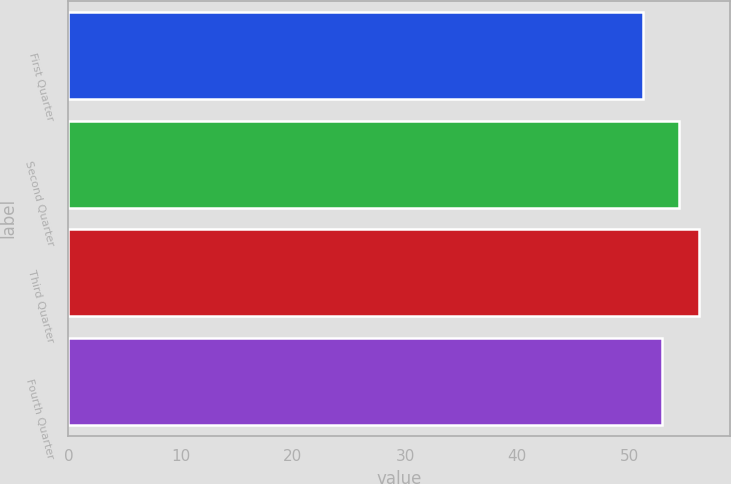Convert chart. <chart><loc_0><loc_0><loc_500><loc_500><bar_chart><fcel>First Quarter<fcel>Second Quarter<fcel>Third Quarter<fcel>Fourth Quarter<nl><fcel>51.2<fcel>54.4<fcel>56.18<fcel>52.95<nl></chart> 